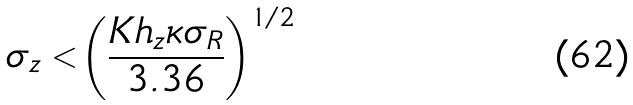Convert formula to latex. <formula><loc_0><loc_0><loc_500><loc_500>\sigma _ { z } < \left ( \frac { K h _ { z } \kappa \sigma _ { R } } { 3 . 3 6 } \right ) ^ { 1 / 2 }</formula> 